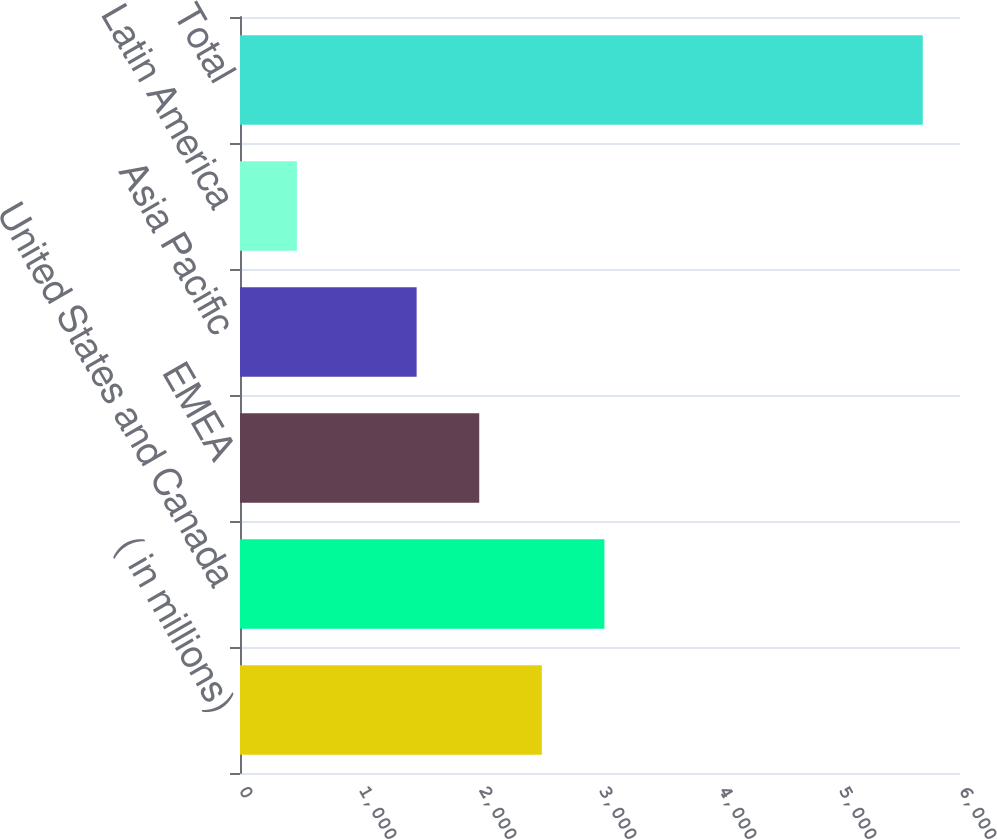Convert chart to OTSL. <chart><loc_0><loc_0><loc_500><loc_500><bar_chart><fcel>( in millions)<fcel>United States and Canada<fcel>EMEA<fcel>Asia Pacific<fcel>Latin America<fcel>Total<nl><fcel>2515.2<fcel>3036.8<fcel>1993.6<fcel>1472<fcel>474<fcel>5690<nl></chart> 